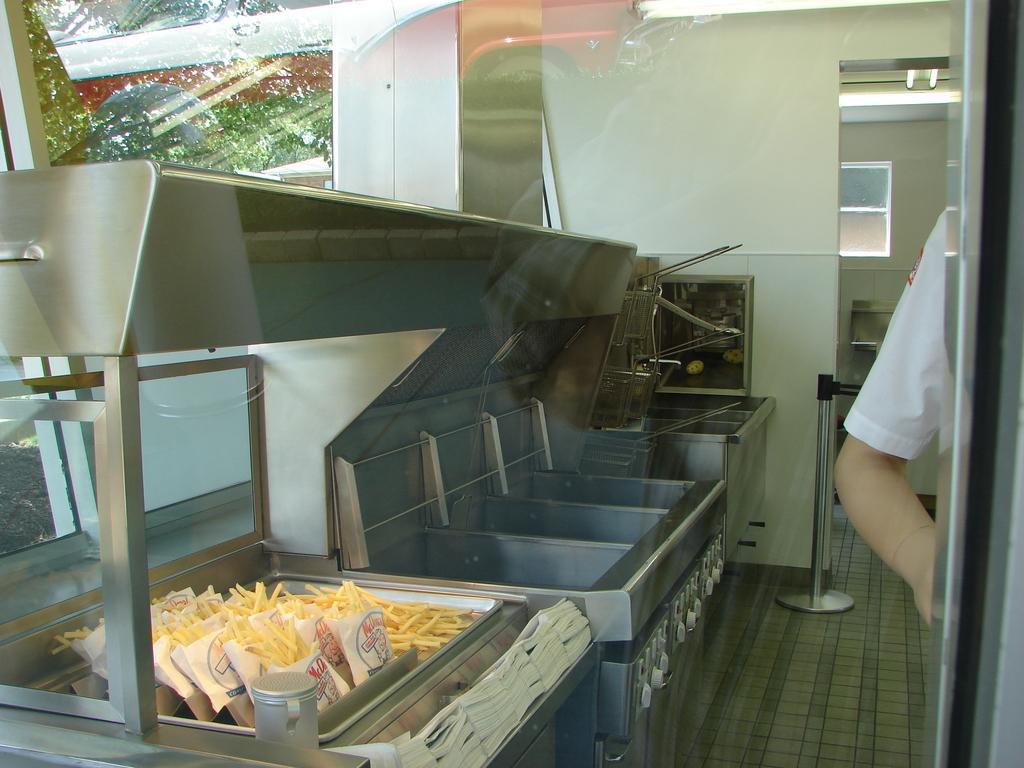Describe this image in one or two sentences. In this image we can see the inner view of a kitchen, here we can see a person's hand, some food items, covers, glass windows and stand here. Here we can see the reflection of trees and a vehicle. 